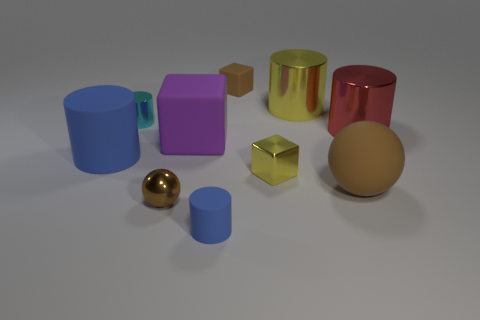The tiny yellow thing is what shape?
Your answer should be compact. Cube. How many other objects are there of the same size as the yellow cube?
Provide a succinct answer. 4. Does the big brown object have the same shape as the small yellow shiny thing?
Provide a short and direct response. No. Is there any other thing of the same color as the small shiny sphere?
Keep it short and to the point. Yes. There is a brown object that is in front of the yellow shiny cylinder and to the left of the brown matte sphere; what is its shape?
Offer a terse response. Sphere. Is the number of small brown balls to the right of the small blue cylinder the same as the number of large cylinders behind the large rubber block?
Your answer should be very brief. No. How many cylinders are large purple things or metallic things?
Offer a terse response. 3. What number of small brown things are the same material as the small yellow object?
Your answer should be compact. 1. There is a big object that is the same color as the small metallic cube; what is its shape?
Offer a terse response. Cylinder. What material is the large cylinder that is in front of the big yellow shiny object and to the right of the tiny shiny ball?
Your answer should be very brief. Metal. 